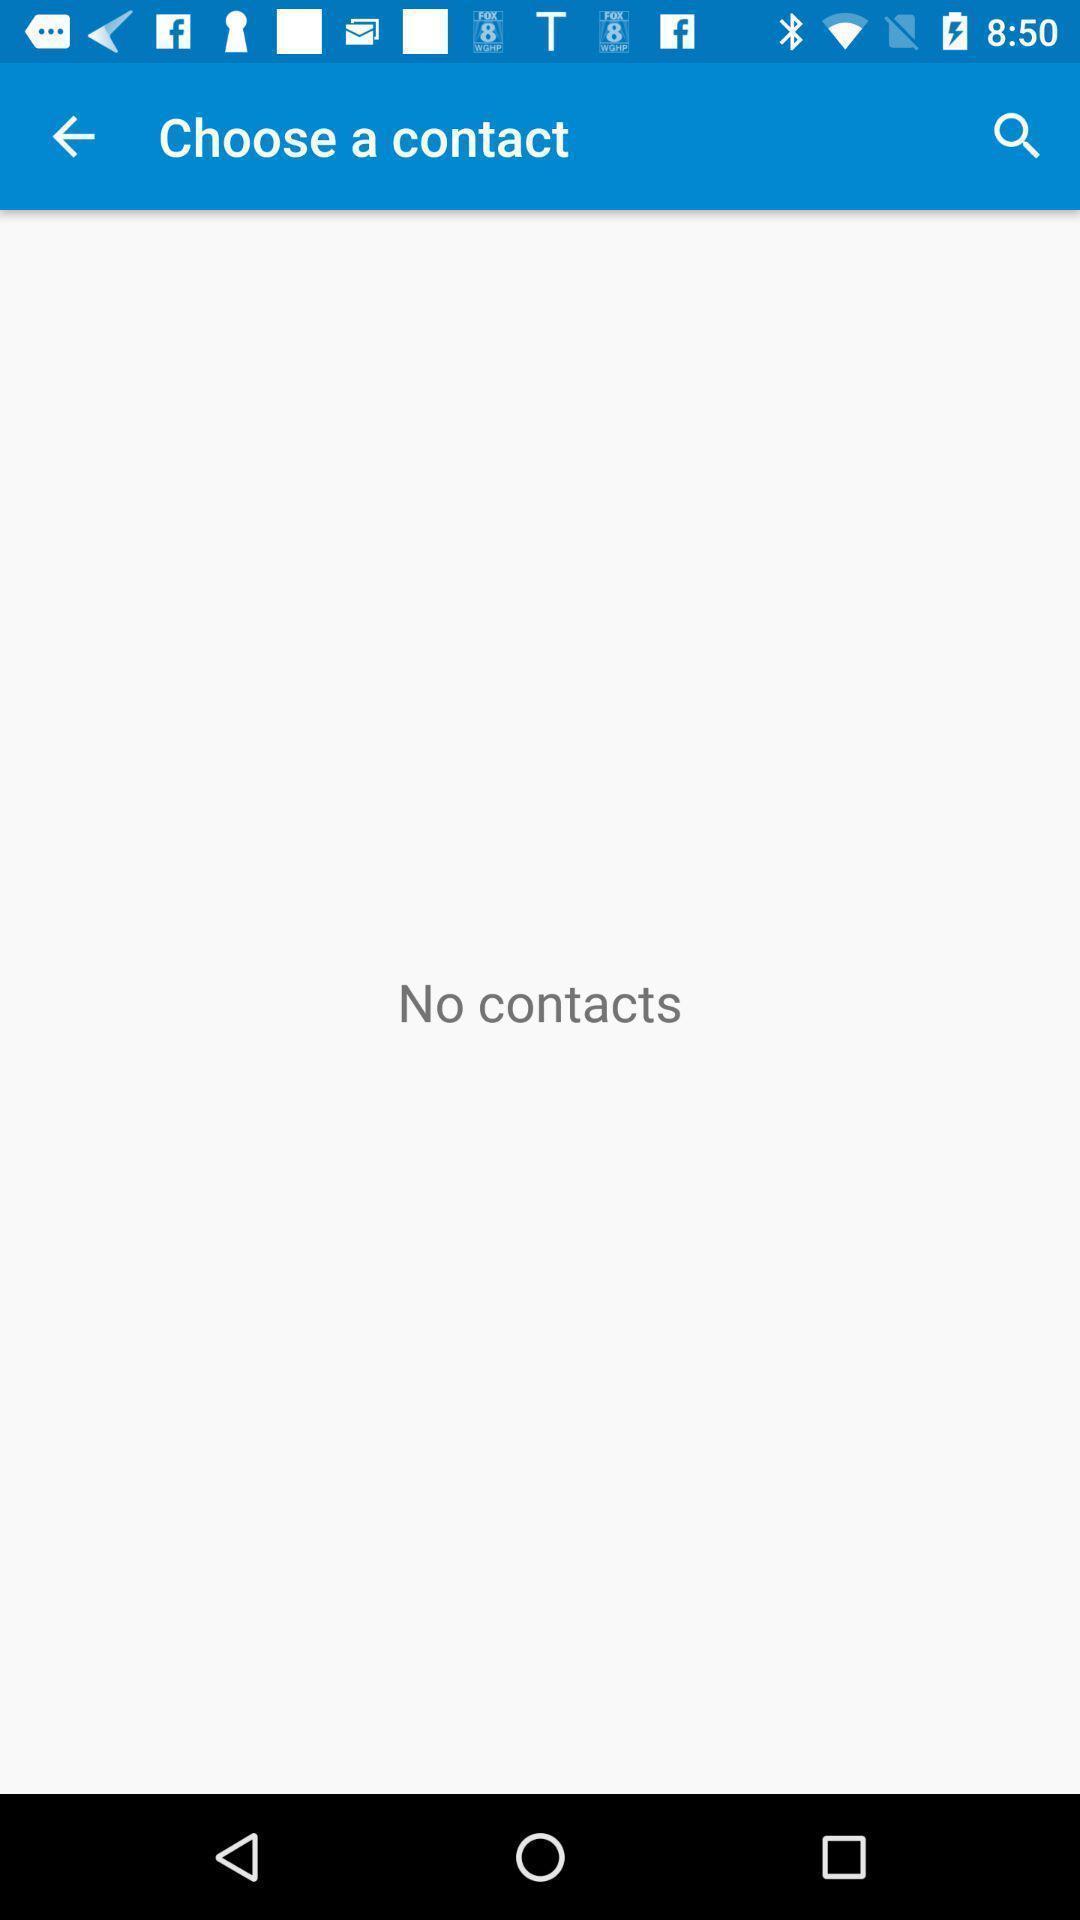Tell me what you see in this picture. Page for choosing a contact. 